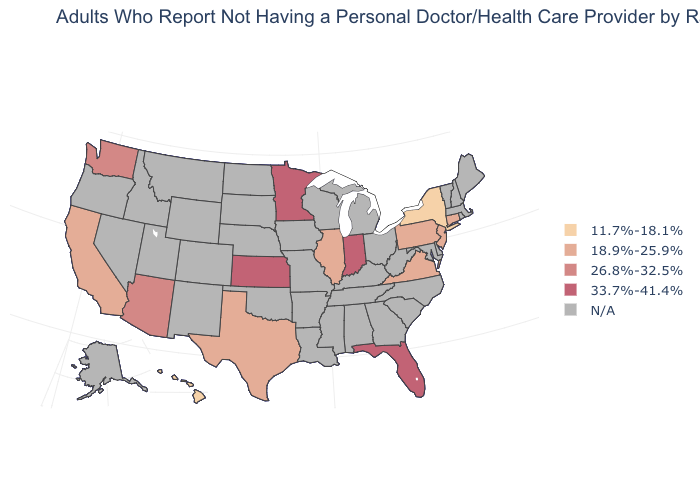Does the first symbol in the legend represent the smallest category?
Write a very short answer. Yes. What is the value of Massachusetts?
Concise answer only. N/A. What is the value of Iowa?
Short answer required. N/A. Which states hav the highest value in the Northeast?
Concise answer only. Connecticut, New Jersey, Pennsylvania. Name the states that have a value in the range 18.9%-25.9%?
Answer briefly. California, Connecticut, Illinois, New Jersey, Pennsylvania, Texas, Virginia. Name the states that have a value in the range 18.9%-25.9%?
Keep it brief. California, Connecticut, Illinois, New Jersey, Pennsylvania, Texas, Virginia. How many symbols are there in the legend?
Write a very short answer. 5. Does the map have missing data?
Write a very short answer. Yes. Does the first symbol in the legend represent the smallest category?
Write a very short answer. Yes. Does New York have the highest value in the Northeast?
Answer briefly. No. Does the map have missing data?
Give a very brief answer. Yes. What is the value of Hawaii?
Concise answer only. 11.7%-18.1%. Which states have the lowest value in the USA?
Short answer required. Hawaii, New York. Name the states that have a value in the range 33.7%-41.4%?
Quick response, please. Florida, Indiana, Kansas, Minnesota. 